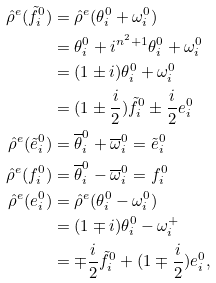<formula> <loc_0><loc_0><loc_500><loc_500>\hat { \rho } ^ { e } ( \tilde { f } _ { i } ^ { 0 } ) & = \hat { \rho } ^ { e } ( \theta ^ { 0 } _ { i } + \omega _ { i } ^ { 0 } ) \\ & = \theta _ { i } ^ { 0 } + i ^ { n ^ { 2 } + 1 } \theta _ { i } ^ { 0 } + \omega ^ { 0 } _ { i } \\ & = ( 1 \pm i ) \theta _ { i } ^ { 0 } + \omega _ { i } ^ { 0 } \\ & = ( 1 \pm \frac { i } { 2 } ) \tilde { f } _ { i } ^ { 0 } \pm \frac { i } { 2 } e _ { i } ^ { 0 } \\ \hat { \rho } ^ { e } ( \tilde { e } _ { i } ^ { 0 } ) & = \overline { \theta } _ { i } ^ { 0 } + \overline { \omega } _ { i } ^ { 0 } = \tilde { e } _ { i } ^ { 0 } \\ \hat { \rho } ^ { e } ( f _ { i } ^ { 0 } ) & = \overline { \theta } _ { i } ^ { 0 } - \overline { \omega } _ { i } ^ { 0 } = f _ { i } ^ { 0 } \\ \hat { \rho } ^ { e } ( e _ { i } ^ { 0 } ) & = \hat { \rho } ^ { e } ( \theta ^ { 0 } _ { i } - \omega _ { i } ^ { 0 } ) \\ & = ( 1 \mp i ) \theta _ { i } ^ { 0 } - \omega ^ { + } _ { i } \\ & = \mp \frac { i } { 2 } \tilde { f } _ { i } ^ { 0 } + ( 1 \mp \frac { i } { 2 } ) e _ { i } ^ { 0 } ,</formula> 